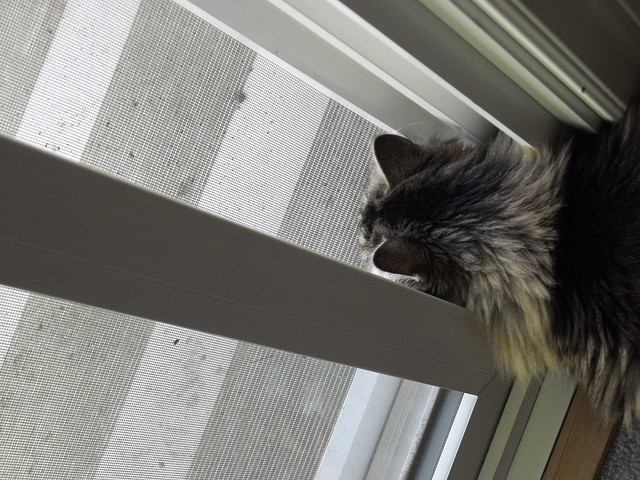Describe the objects in this image and their specific colors. I can see a cat in darkgray, black, and gray tones in this image. 